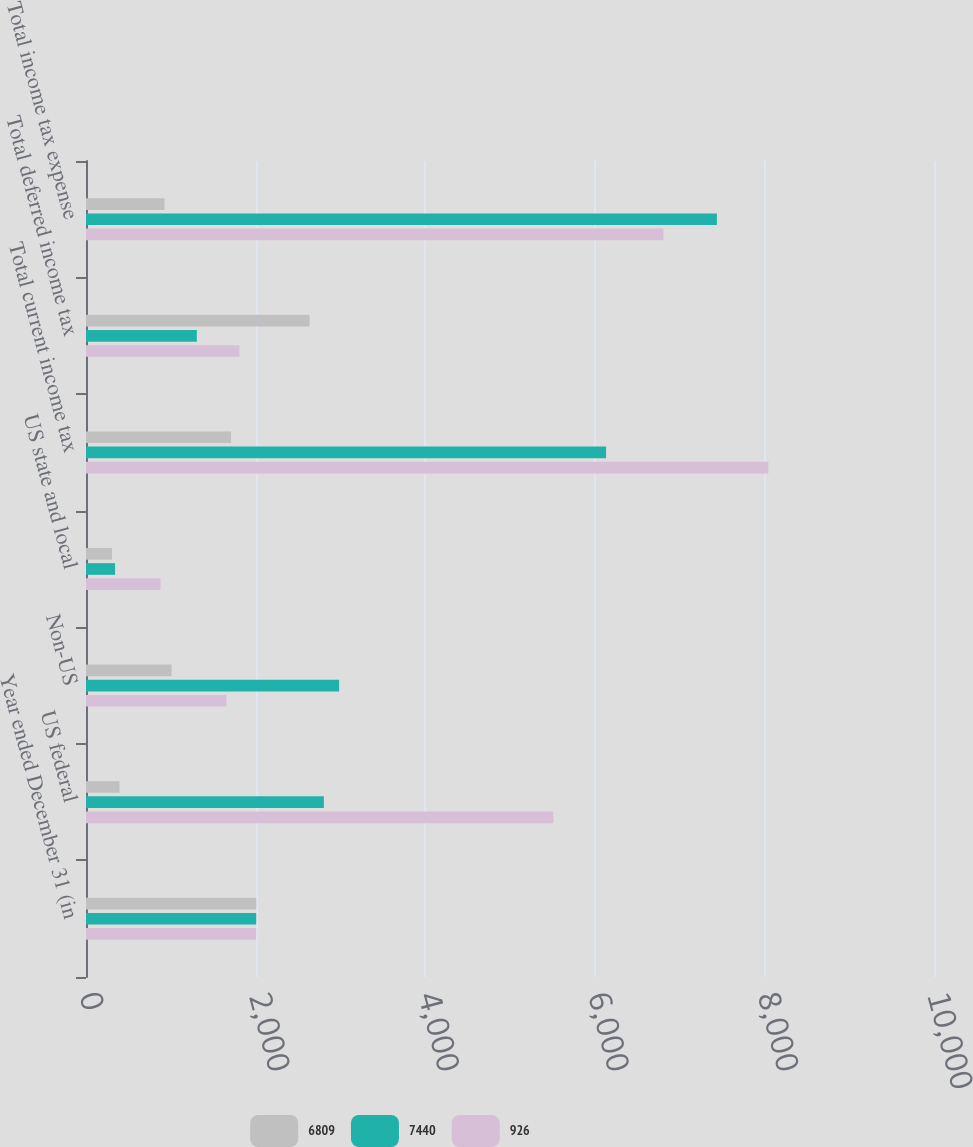Convert chart. <chart><loc_0><loc_0><loc_500><loc_500><stacked_bar_chart><ecel><fcel>Year ended December 31 (in<fcel>US federal<fcel>Non-US<fcel>US state and local<fcel>Total current income tax<fcel>Total deferred income tax<fcel>Total income tax expense<nl><fcel>6809<fcel>2008<fcel>395<fcel>1009<fcel>307<fcel>1711<fcel>2637<fcel>926<nl><fcel>7440<fcel>2007<fcel>2805<fcel>2985<fcel>343<fcel>6133<fcel>1307<fcel>7440<nl><fcel>926<fcel>2006<fcel>5512<fcel>1656<fcel>879<fcel>8047<fcel>1810<fcel>6809<nl></chart> 